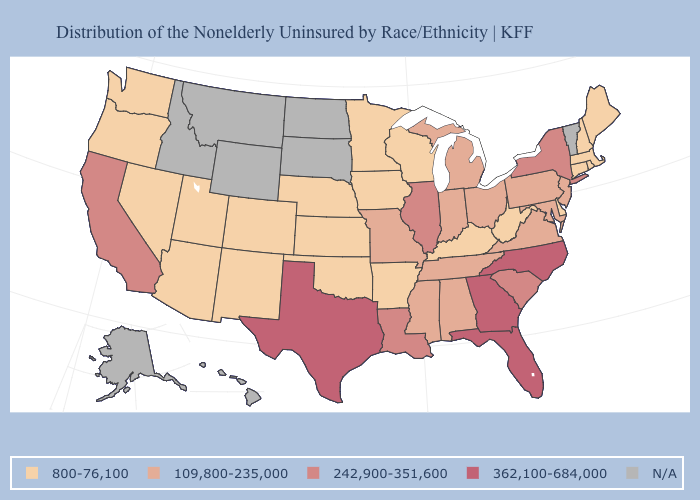Is the legend a continuous bar?
Quick response, please. No. Which states have the lowest value in the USA?
Be succinct. Arizona, Arkansas, Colorado, Connecticut, Delaware, Iowa, Kansas, Kentucky, Maine, Massachusetts, Minnesota, Nebraska, Nevada, New Hampshire, New Mexico, Oklahoma, Oregon, Rhode Island, Utah, Washington, West Virginia, Wisconsin. What is the highest value in states that border Vermont?
Write a very short answer. 242,900-351,600. Does Colorado have the lowest value in the USA?
Keep it brief. Yes. How many symbols are there in the legend?
Short answer required. 5. What is the value of Alabama?
Be succinct. 109,800-235,000. Name the states that have a value in the range 362,100-684,000?
Short answer required. Florida, Georgia, North Carolina, Texas. What is the value of Pennsylvania?
Short answer required. 109,800-235,000. Name the states that have a value in the range 362,100-684,000?
Concise answer only. Florida, Georgia, North Carolina, Texas. What is the value of Vermont?
Keep it brief. N/A. What is the highest value in the USA?
Short answer required. 362,100-684,000. Name the states that have a value in the range 362,100-684,000?
Be succinct. Florida, Georgia, North Carolina, Texas. Name the states that have a value in the range 242,900-351,600?
Be succinct. California, Illinois, Louisiana, New York, South Carolina. Which states have the highest value in the USA?
Answer briefly. Florida, Georgia, North Carolina, Texas. What is the value of Wyoming?
Give a very brief answer. N/A. 